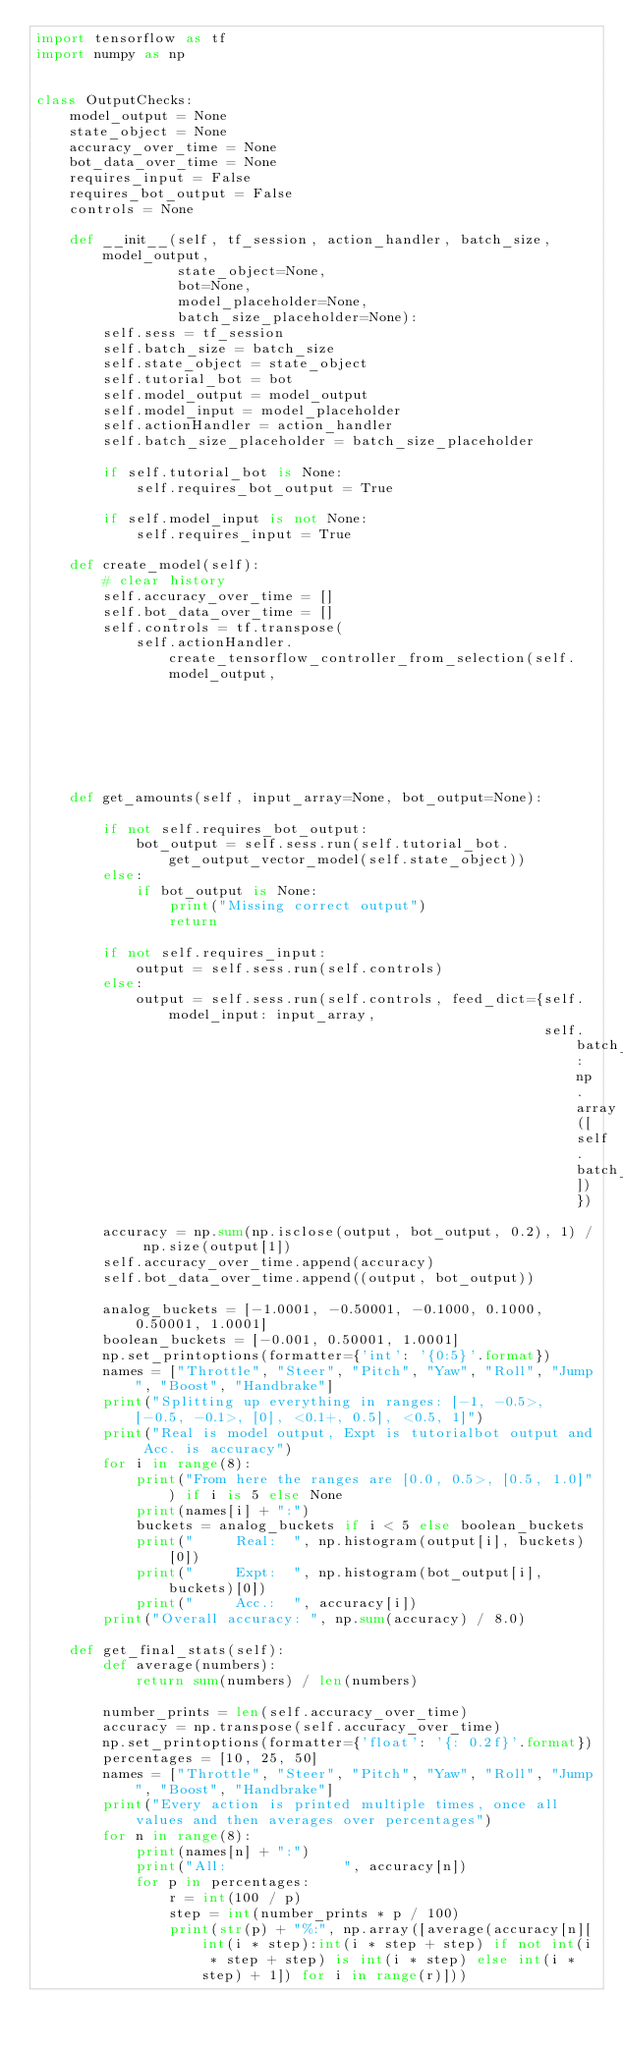Convert code to text. <code><loc_0><loc_0><loc_500><loc_500><_Python_>import tensorflow as tf
import numpy as np


class OutputChecks:
    model_output = None
    state_object = None
    accuracy_over_time = None
    bot_data_over_time = None
    requires_input = False
    requires_bot_output = False
    controls = None

    def __init__(self, tf_session, action_handler, batch_size, model_output,
                 state_object=None,
                 bot=None,
                 model_placeholder=None,
                 batch_size_placeholder=None):
        self.sess = tf_session
        self.batch_size = batch_size
        self.state_object = state_object
        self.tutorial_bot = bot
        self.model_output = model_output
        self.model_input = model_placeholder
        self.actionHandler = action_handler
        self.batch_size_placeholder = batch_size_placeholder

        if self.tutorial_bot is None:
            self.requires_bot_output = True

        if self.model_input is not None:
            self.requires_input = True

    def create_model(self):
        # clear history
        self.accuracy_over_time = []
        self.bot_data_over_time = []
        self.controls = tf.transpose(
            self.actionHandler.create_tensorflow_controller_from_selection(self.model_output,
                                                                           self.batch_size))

    def get_amounts(self, input_array=None, bot_output=None):

        if not self.requires_bot_output:
            bot_output = self.sess.run(self.tutorial_bot.get_output_vector_model(self.state_object))
        else:
            if bot_output is None:
                print("Missing correct output")
                return

        if not self.requires_input:
            output = self.sess.run(self.controls)
        else:
            output = self.sess.run(self.controls, feed_dict={self.model_input: input_array,
                                                             self.batch_size_placeholder: np.array([self.batch_size])})

        accuracy = np.sum(np.isclose(output, bot_output, 0.2), 1) / np.size(output[1])
        self.accuracy_over_time.append(accuracy)
        self.bot_data_over_time.append((output, bot_output))

        analog_buckets = [-1.0001, -0.50001, -0.1000, 0.1000, 0.50001, 1.0001]
        boolean_buckets = [-0.001, 0.50001, 1.0001]
        np.set_printoptions(formatter={'int': '{0:5}'.format})
        names = ["Throttle", "Steer", "Pitch", "Yaw", "Roll", "Jump", "Boost", "Handbrake"]
        print("Splitting up everything in ranges: [-1, -0.5>, [-0.5, -0.1>, [0], <0.1+, 0.5], <0.5, 1]")
        print("Real is model output, Expt is tutorialbot output and Acc. is accuracy")
        for i in range(8):
            print("From here the ranges are [0.0, 0.5>, [0.5, 1.0]") if i is 5 else None
            print(names[i] + ":")
            buckets = analog_buckets if i < 5 else boolean_buckets
            print("     Real:  ", np.histogram(output[i], buckets)[0])
            print("     Expt:  ", np.histogram(bot_output[i], buckets)[0])
            print("     Acc.:  ", accuracy[i])
        print("Overall accuracy: ", np.sum(accuracy) / 8.0)

    def get_final_stats(self):
        def average(numbers):
            return sum(numbers) / len(numbers)

        number_prints = len(self.accuracy_over_time)
        accuracy = np.transpose(self.accuracy_over_time)
        np.set_printoptions(formatter={'float': '{: 0.2f}'.format})
        percentages = [10, 25, 50]
        names = ["Throttle", "Steer", "Pitch", "Yaw", "Roll", "Jump", "Boost", "Handbrake"]
        print("Every action is printed multiple times, once all values and then averages over percentages")
        for n in range(8):
            print(names[n] + ":")
            print("All:              ", accuracy[n])
            for p in percentages:
                r = int(100 / p)
                step = int(number_prints * p / 100)
                print(str(p) + "%:", np.array([average(accuracy[n][int(i * step):int(i * step + step) if not int(i * step + step) is int(i * step) else int(i * step) + 1]) for i in range(r)]))
</code> 